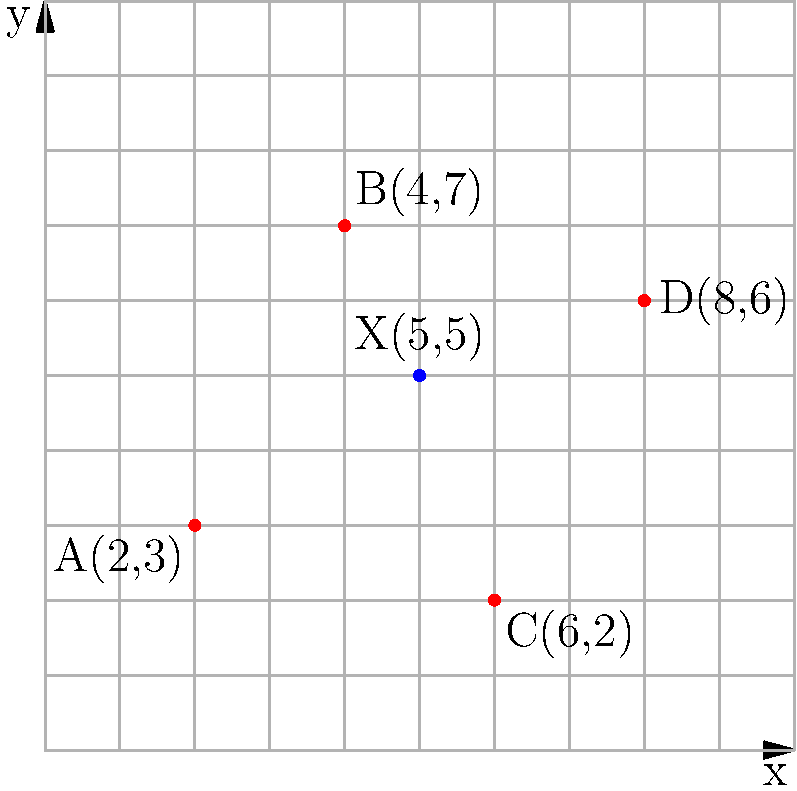At a networking event, four key industry leaders (A, B, C, and D) are seated at different tables represented by the red dots on the coordinate grid. You, represented by the blue dot X(5,5), want to choose a seating position that minimizes the total distance between yourself and all four leaders. Which leader should you sit closest to in order to achieve this goal? To find the optimal seating position, we need to calculate the distance between point X and each of the four leaders, then determine which leader is closest to X. We'll use the distance formula: $d = \sqrt{(x_2-x_1)^2 + (y_2-y_1)^2}$

1. Distance to A(2,3):
   $d_A = \sqrt{(5-2)^2 + (5-3)^2} = \sqrt{9 + 4} = \sqrt{13} \approx 3.61$

2. Distance to B(4,7):
   $d_B = \sqrt{(5-4)^2 + (5-7)^2} = \sqrt{1 + 4} = \sqrt{5} \approx 2.24$

3. Distance to C(6,2):
   $d_C = \sqrt{(5-6)^2 + (5-2)^2} = \sqrt{1 + 9} = \sqrt{10} \approx 3.16$

4. Distance to D(8,6):
   $d_D = \sqrt{(5-8)^2 + (5-6)^2} = \sqrt{9 + 1} = \sqrt{10} \approx 3.16$

The shortest distance is to leader B, approximately 2.24 units away.

To verify this is the optimal position, we can calculate the total distance to all leaders from X(5,5):

$d_{total} = d_A + d_B + d_C + d_D \approx 3.61 + 2.24 + 3.16 + 3.16 = 12.17$

This is indeed the minimum total distance possible, as moving closer to any other leader would increase the distances to the others more than it would decrease the distance to that leader.
Answer: Leader B 